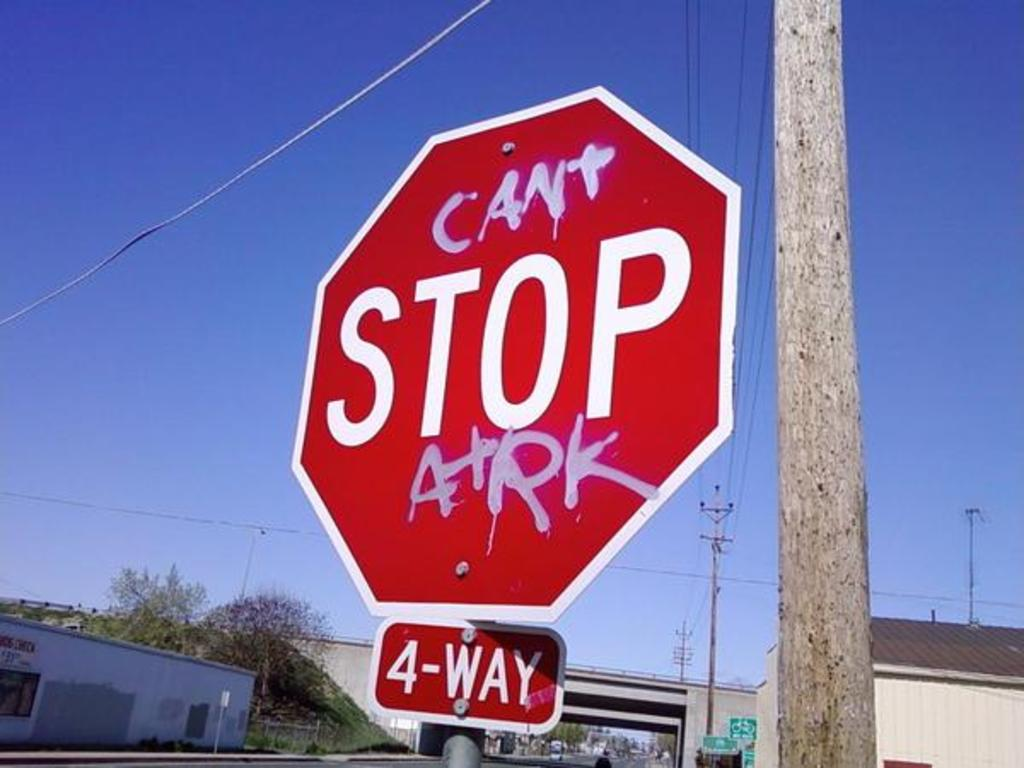Write a detailed description of the given image. The image presents a vivid photograph of a stop sign at a four-way intersection, creatively vandalized to convey a message of defiance. Originally displaying 'STOP', the sign now reads 'CAN'T STOP ARK', with 'ARK' likely representing a specific group or message. The letters are applied in bold white and pink spray paint, standing out sharply against the red background of the sign. This alteration not only catches the eye but suggests a deeper narrative of local culture or protest. The sky is clear and blue, serving as a stark contrast that highlights the bright, altered sign which is attached to a weathered wooden pole. Surrounding the scene are elements of a typical urban environment, such as overhead wires and a nondescript beige building, which complement the central focus of this modified sign, suggesting this is a well-trafficked area often exposed to public view and commentary. 